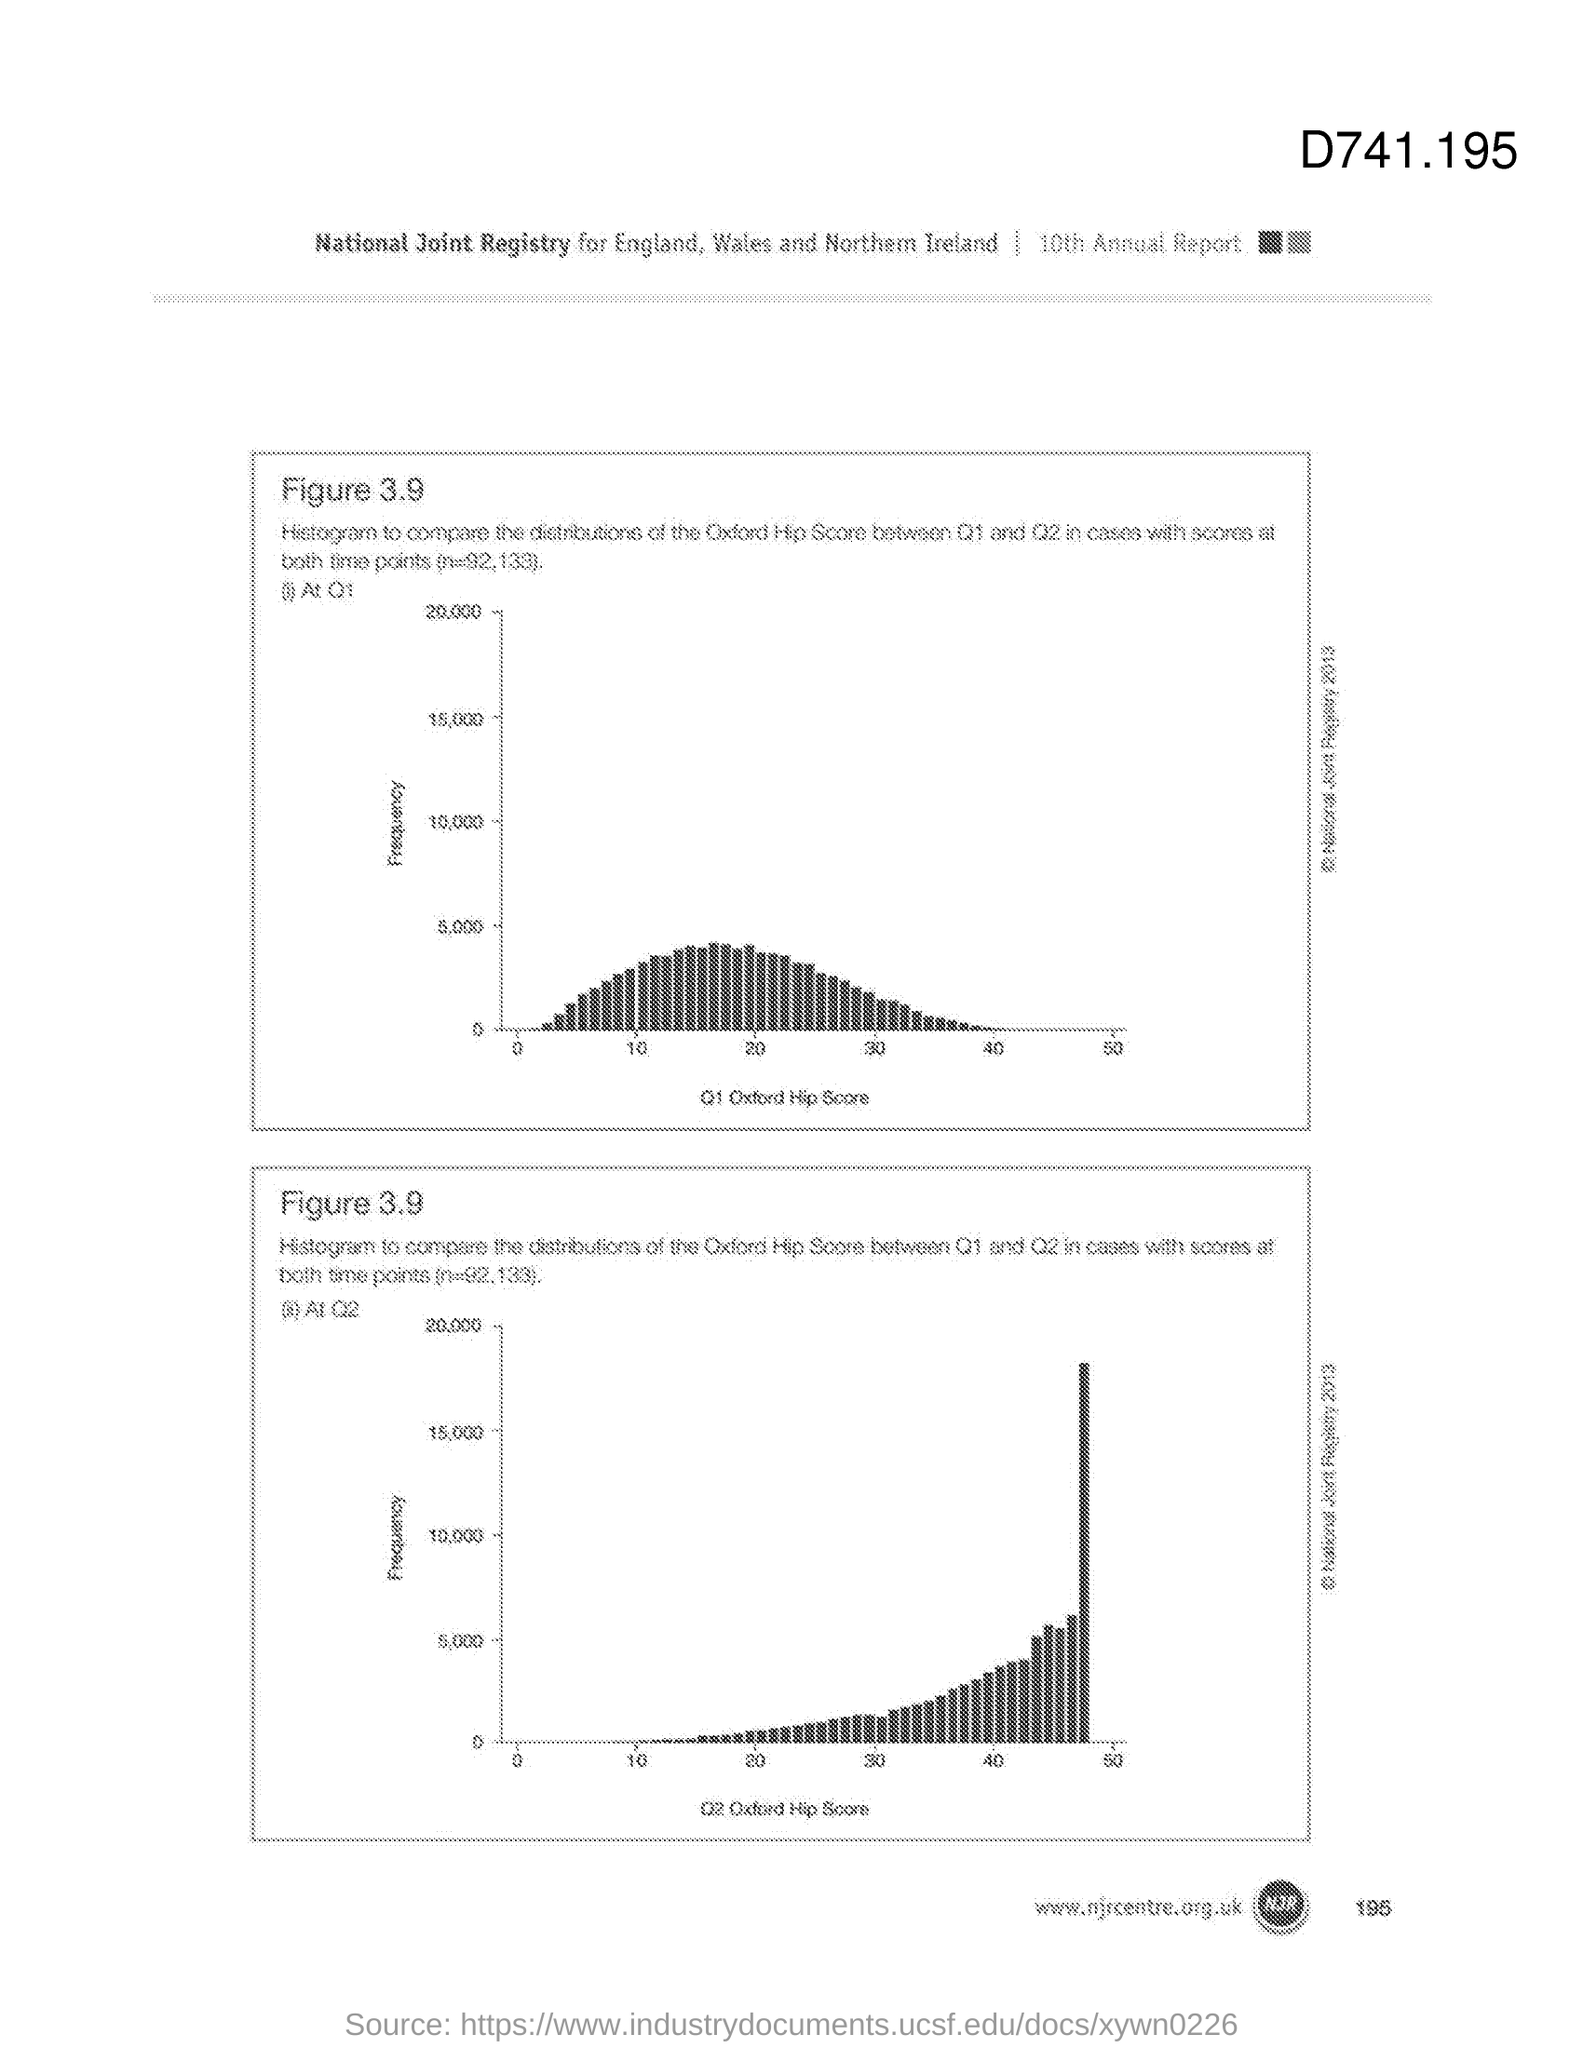Mention a couple of crucial points in this snapshot. The page number is 195. The edition of the annual report is the 10th. The number that is situated at the top right corner of the document is D741.195... The figure number is 3.9. 